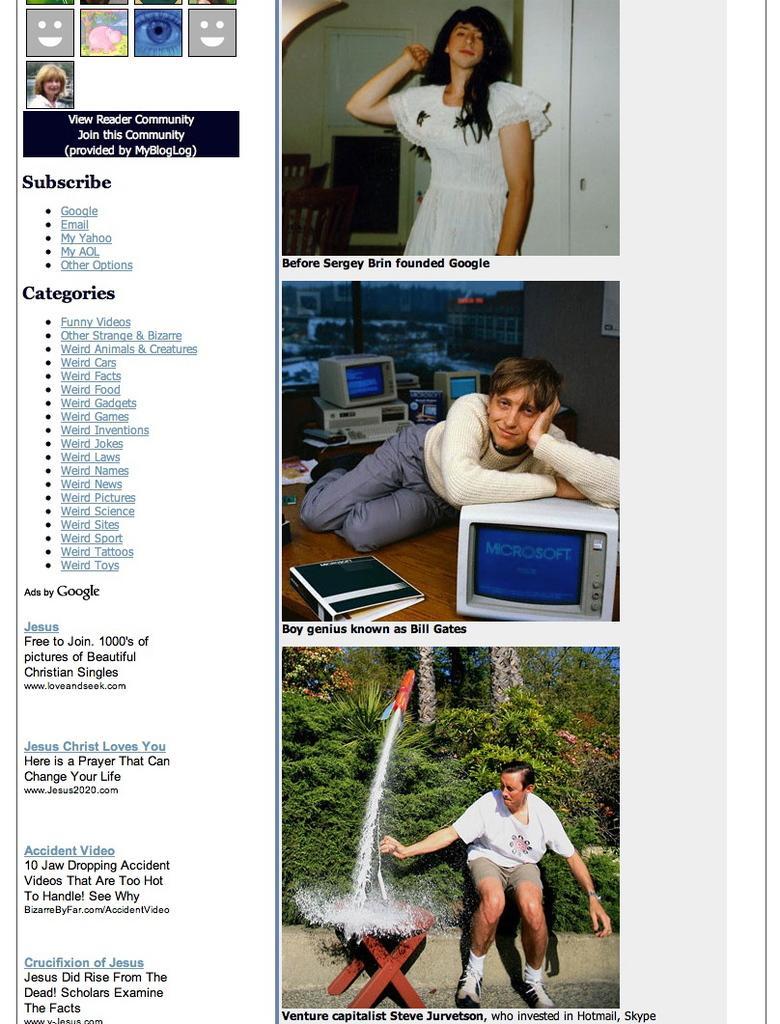Could you give a brief overview of what you see in this image? In this picture we can see it as a collage image here we have woman standing and in this person sleeping keeping his hands on monitor and here it is book and in last person bending and touching water and in background we can see trees. 